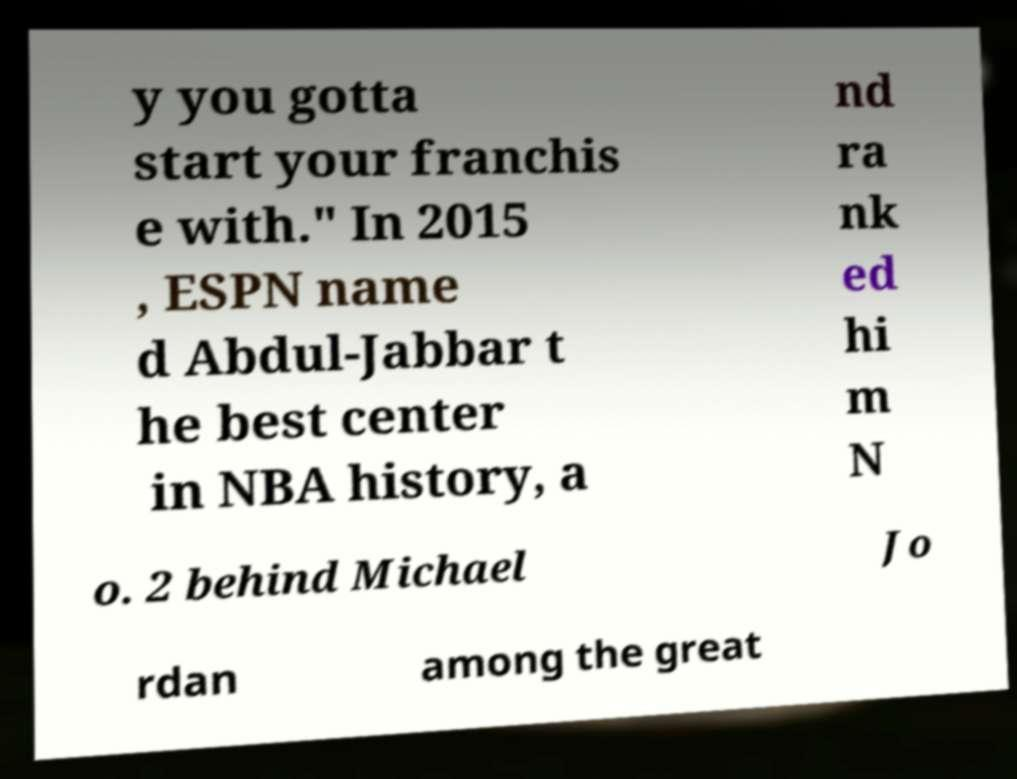There's text embedded in this image that I need extracted. Can you transcribe it verbatim? y you gotta start your franchis e with." In 2015 , ESPN name d Abdul-Jabbar t he best center in NBA history, a nd ra nk ed hi m N o. 2 behind Michael Jo rdan among the great 